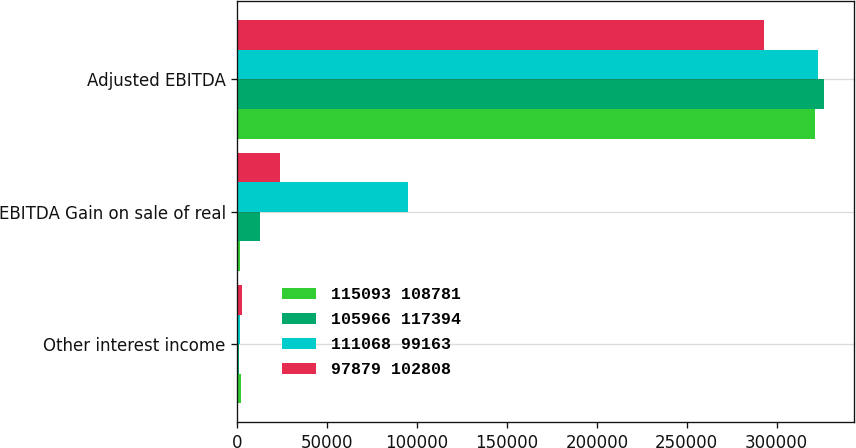Convert chart. <chart><loc_0><loc_0><loc_500><loc_500><stacked_bar_chart><ecel><fcel>Other interest income<fcel>EBITDA Gain on sale of real<fcel>Adjusted EBITDA<nl><fcel>115093 108781<fcel>1894<fcel>1298<fcel>321625<nl><fcel>105966 117394<fcel>919<fcel>12572<fcel>326527<nl><fcel>111068 99163<fcel>1337<fcel>94768<fcel>322792<nl><fcel>97879 102808<fcel>2616<fcel>23956<fcel>292827<nl></chart> 